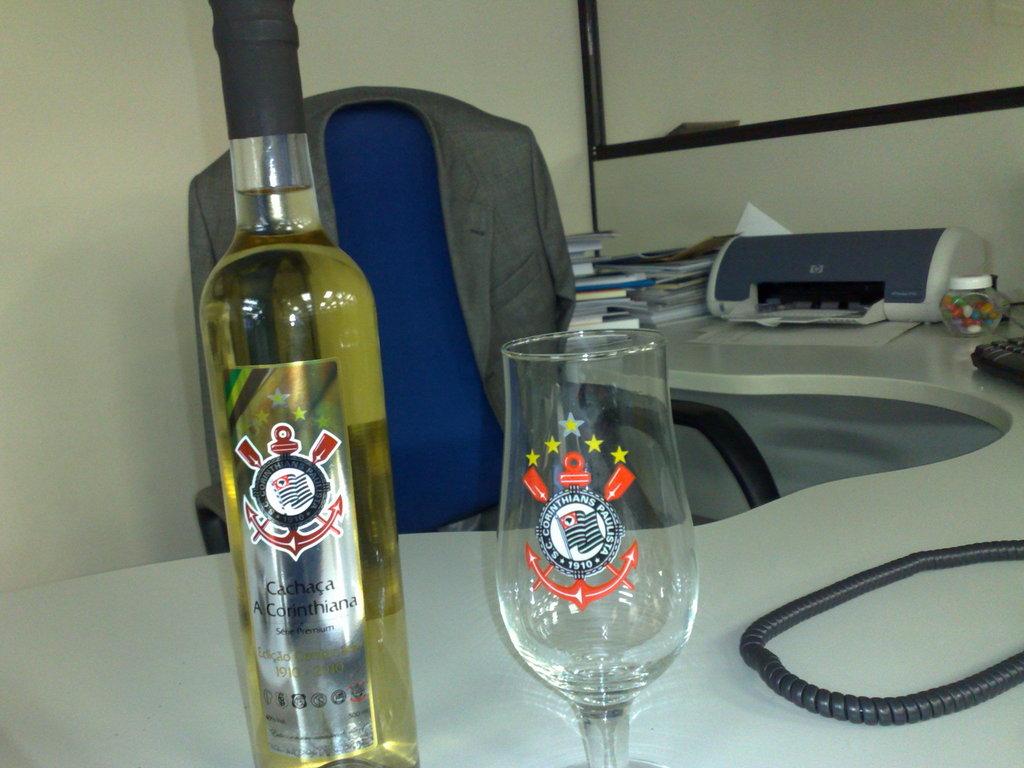What is the name of the bottle on the left?
Provide a succinct answer. Cachaca a corinthiana. 